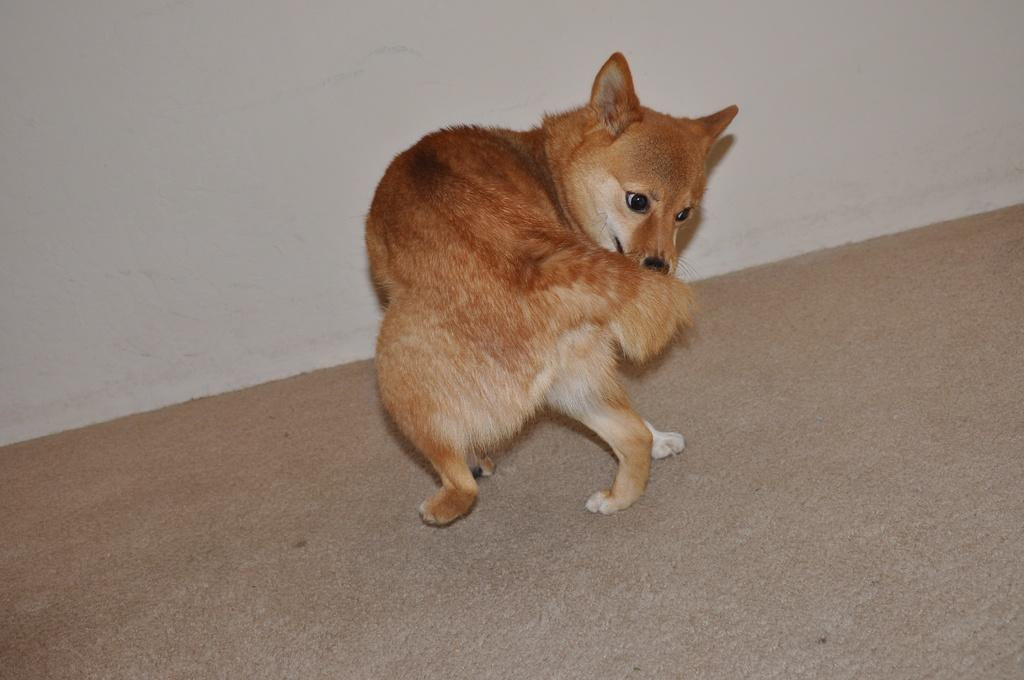What is the main subject in the middle of the image? There is a dog in the middle of the image. What is the surface beneath the dog? There is a floor at the bottom of the image. What can be seen behind the dog? There is a wall in the background of the image. How does the woman balance the unit on her head in the image? There is no woman or unit present in the image; it only features a dog. 